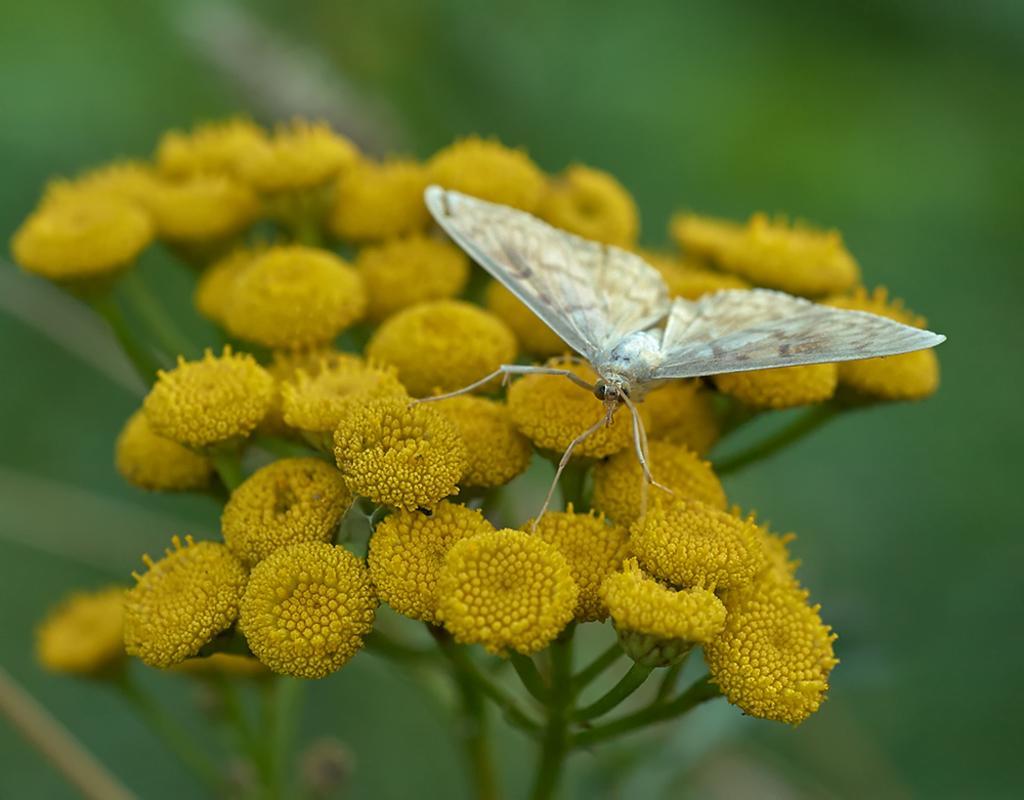Can you describe this image briefly? In this image we can see a butterfly on the flower. 